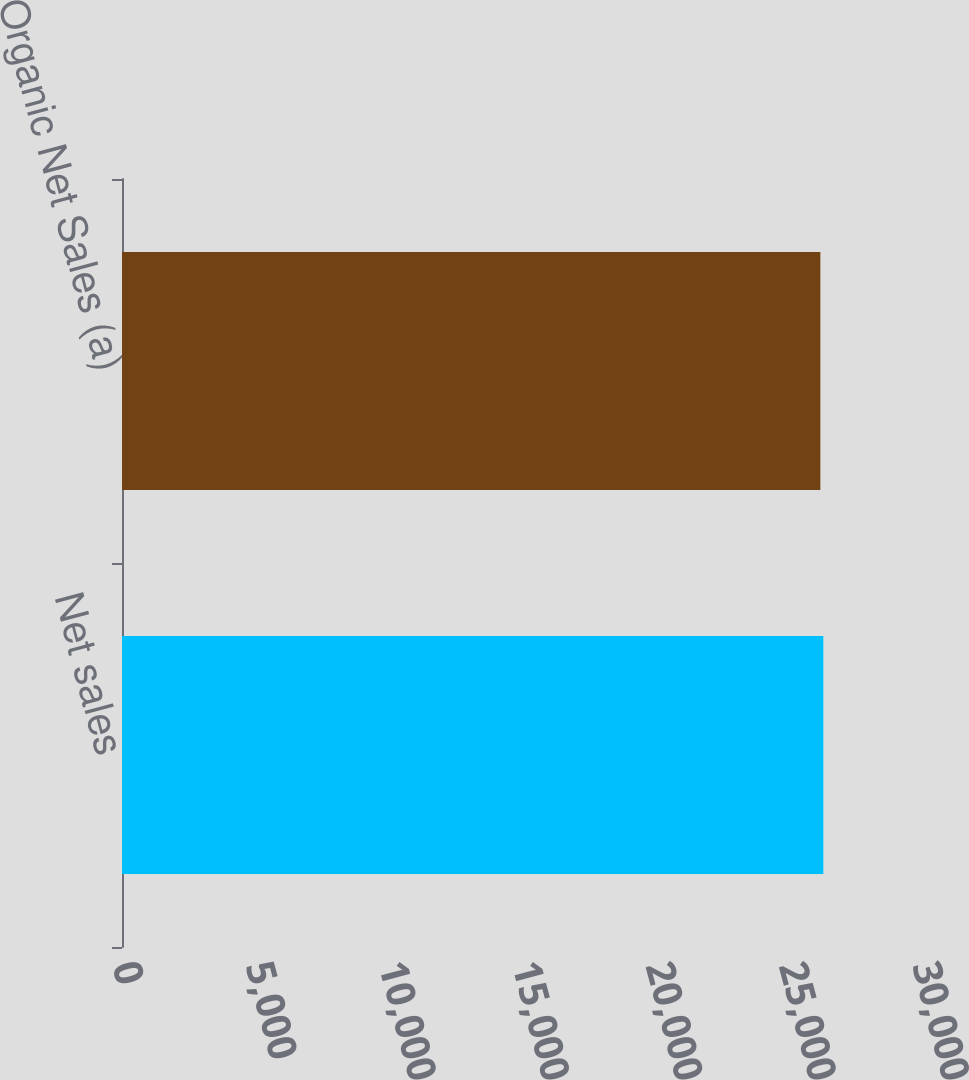<chart> <loc_0><loc_0><loc_500><loc_500><bar_chart><fcel>Net sales<fcel>Organic Net Sales (a)<nl><fcel>26300<fcel>26188<nl></chart> 